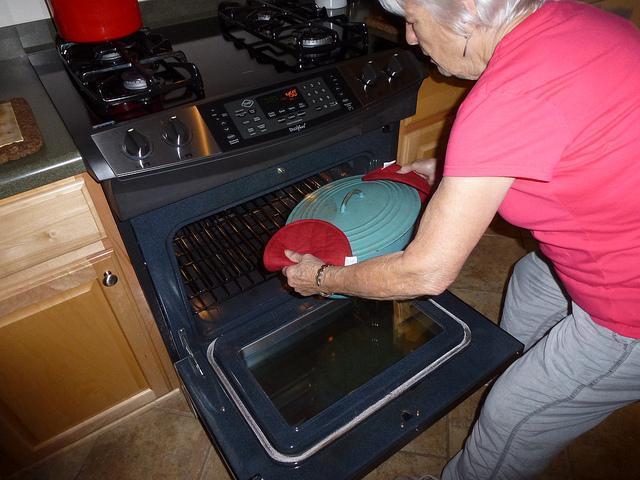How many cars are shown?
Give a very brief answer. 0. 